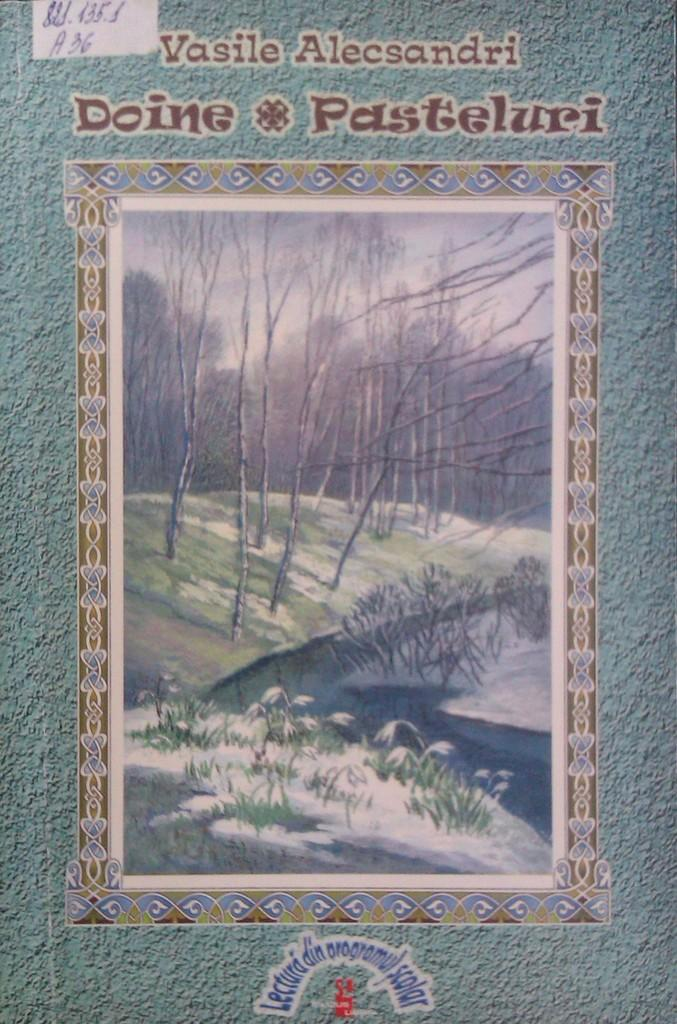What type of vegetation is present in the image? There are many trees in the image. What other natural elements can be seen in the image? There are stones and grass visible in the image. What is the weather like in the image? There is snow visible in the image, indicating a cold or wintry environment. What part of the natural environment is not visible in the image? The ground is not visible in the image, as it is covered by snow. What is visible in the sky in the image? The sky is visible in the image. How many legs can be seen on the crib in the image? There is no crib present in the image; it features trees, stones, snow, grass, and the sky. What type of straw is used to decorate the trees in the image? There is no straw present in the image; it features trees, stones, snow, grass, and the sky. 